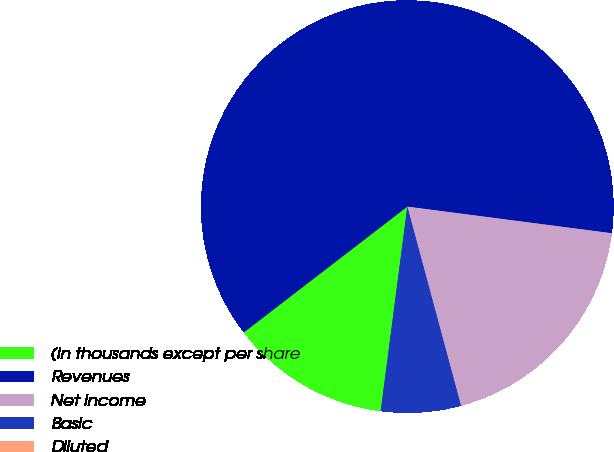Convert chart. <chart><loc_0><loc_0><loc_500><loc_500><pie_chart><fcel>(In thousands except per share<fcel>Revenues<fcel>Net income<fcel>Basic<fcel>Diluted<nl><fcel>12.5%<fcel>62.5%<fcel>18.75%<fcel>6.25%<fcel>0.0%<nl></chart> 